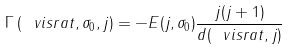Convert formula to latex. <formula><loc_0><loc_0><loc_500><loc_500>\Gamma \left ( \ v i s r a t , \sigma _ { 0 } , j \right ) = - E ( j , \sigma _ { 0 } ) \frac { j ( j + 1 ) } { d ( \ v i s r a t , j ) }</formula> 